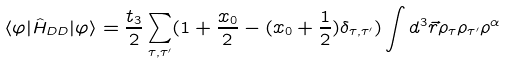Convert formula to latex. <formula><loc_0><loc_0><loc_500><loc_500>\langle \varphi | \hat { H } _ { D D } | \varphi \rangle = \frac { t _ { 3 } } { 2 } \sum _ { \tau , \tau ^ { \prime } } ( 1 + \frac { x _ { 0 } } { 2 } - ( x _ { 0 } + \frac { 1 } { 2 } ) \delta _ { \tau , \tau ^ { \prime } } ) \int d ^ { 3 } \vec { r } \rho _ { \tau } \rho _ { \tau ^ { \prime } } \rho ^ { \alpha }</formula> 